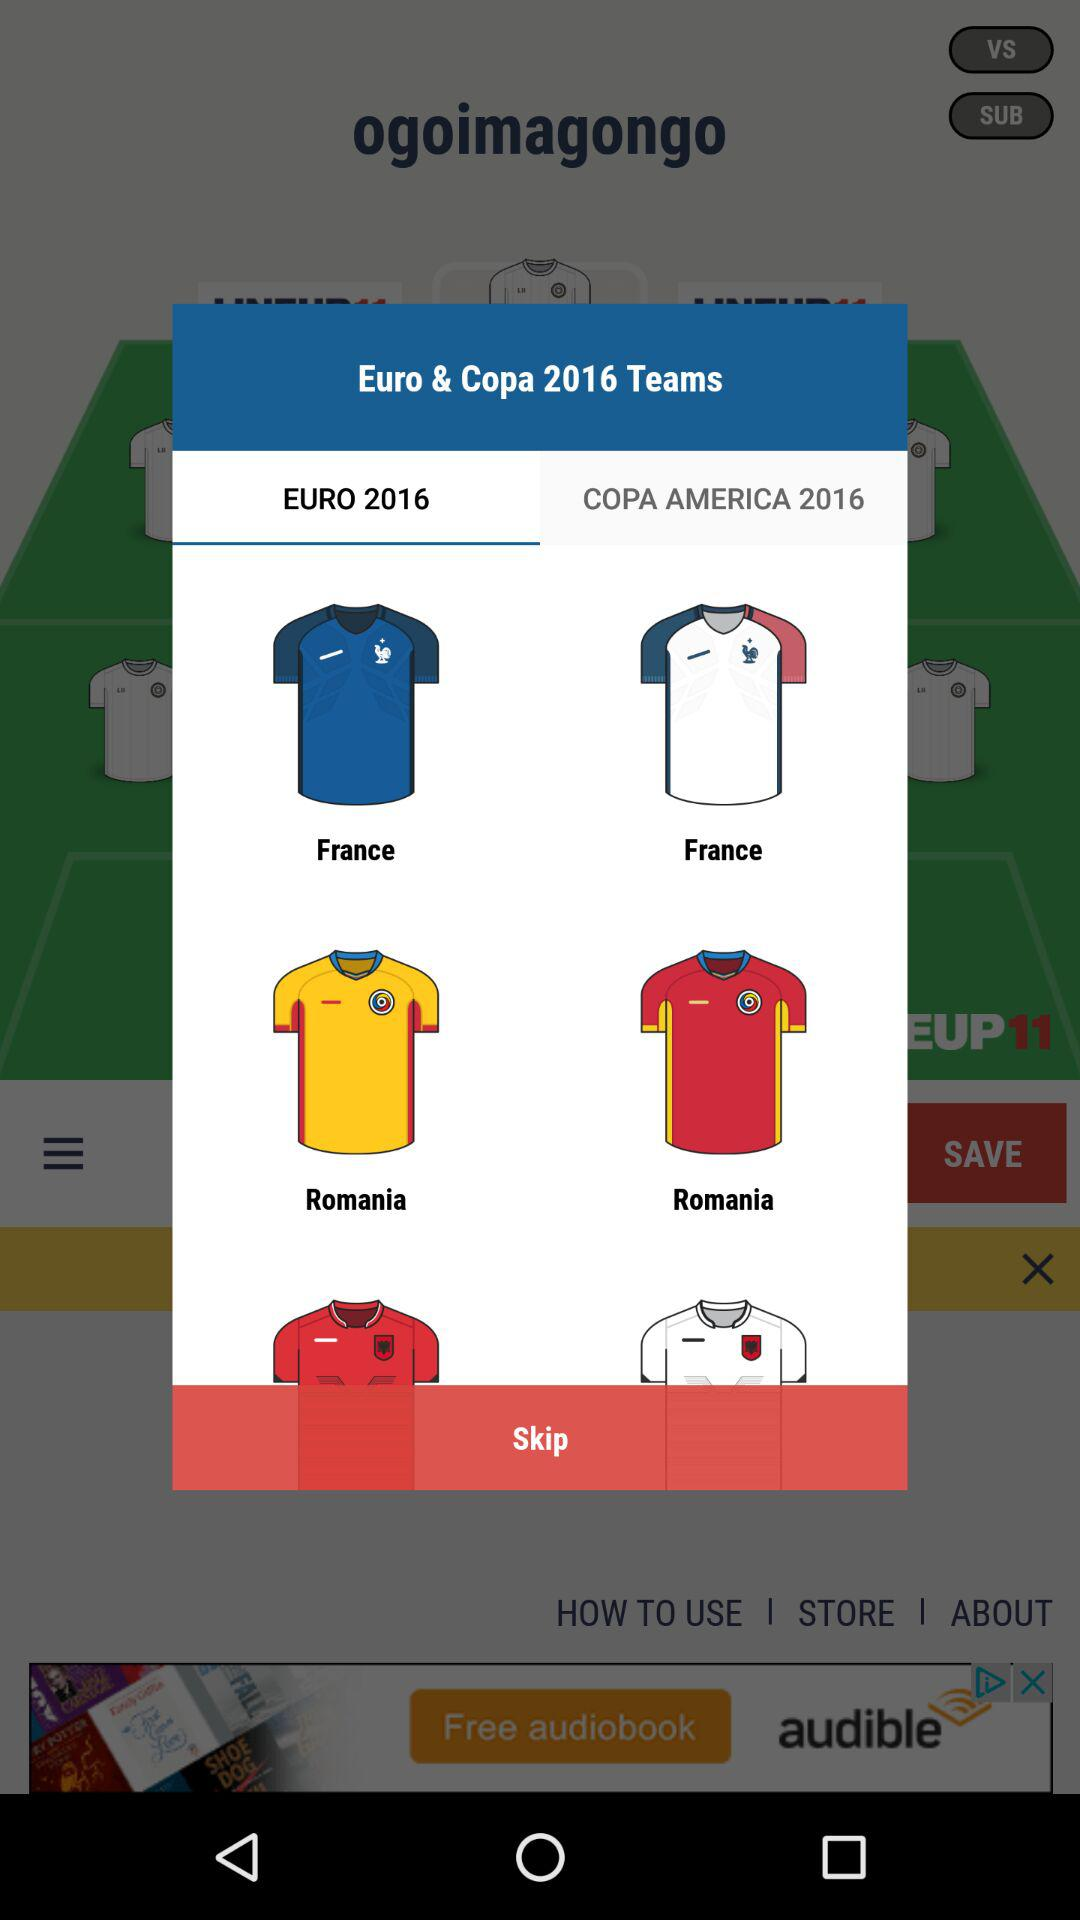What are the team names? The team names are "France" and "Romania". 